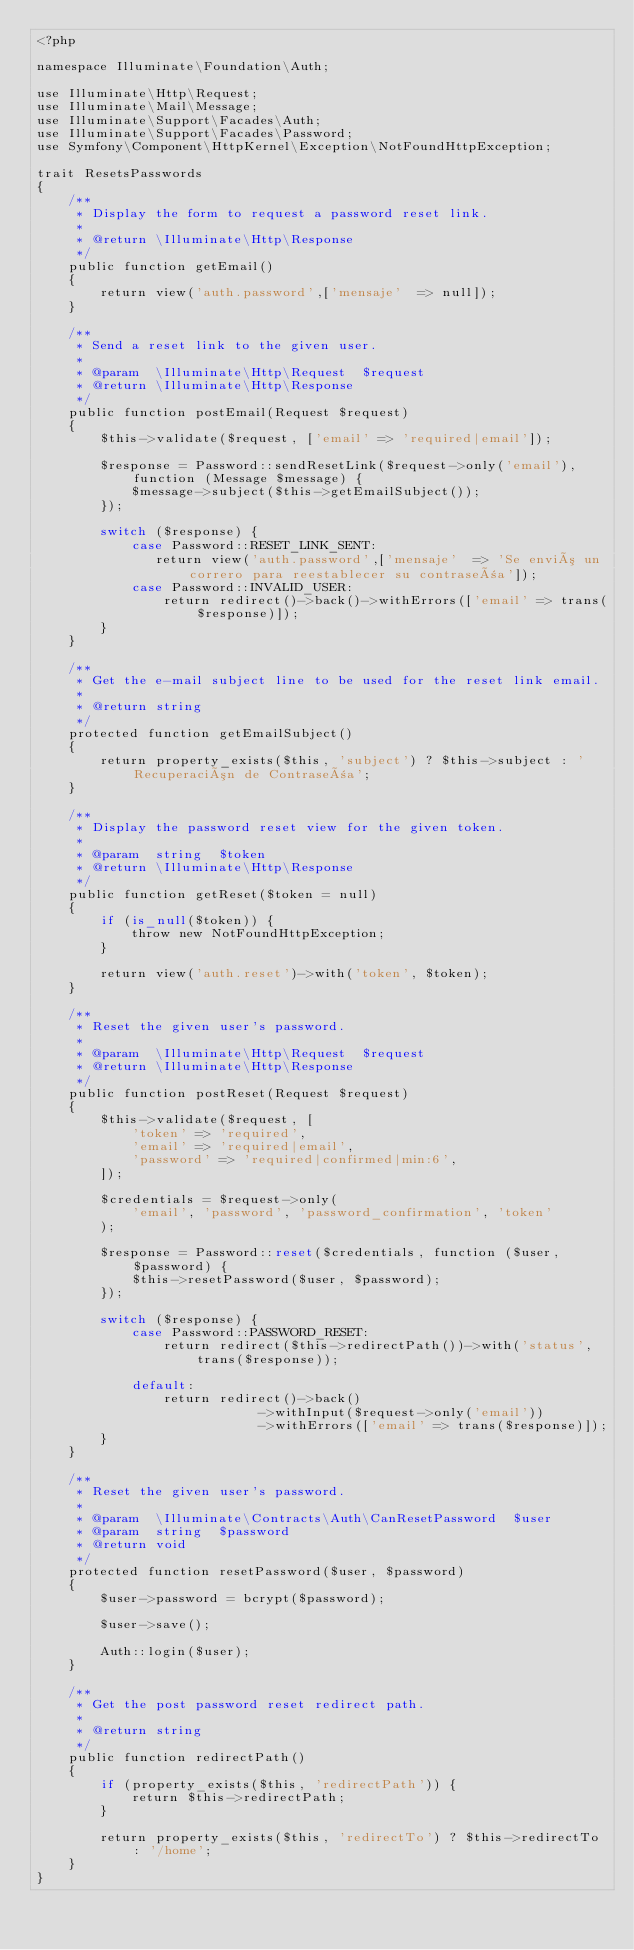Convert code to text. <code><loc_0><loc_0><loc_500><loc_500><_PHP_><?php

namespace Illuminate\Foundation\Auth;

use Illuminate\Http\Request;
use Illuminate\Mail\Message;
use Illuminate\Support\Facades\Auth;
use Illuminate\Support\Facades\Password;
use Symfony\Component\HttpKernel\Exception\NotFoundHttpException;

trait ResetsPasswords
{
    /**
     * Display the form to request a password reset link.
     *
     * @return \Illuminate\Http\Response
     */
    public function getEmail()
    {
        return view('auth.password',['mensaje'  => null]);
    }

    /**
     * Send a reset link to the given user.
     *
     * @param  \Illuminate\Http\Request  $request
     * @return \Illuminate\Http\Response
     */
    public function postEmail(Request $request)
    {
        $this->validate($request, ['email' => 'required|email']);

        $response = Password::sendResetLink($request->only('email'), function (Message $message) {
            $message->subject($this->getEmailSubject());
        });

        switch ($response) {
            case Password::RESET_LINK_SENT:
               return view('auth.password',['mensaje'  => 'Se envió un correro para reestablecer su contraseña']);
            case Password::INVALID_USER:
                return redirect()->back()->withErrors(['email' => trans($response)]);
        }
    }

    /**
     * Get the e-mail subject line to be used for the reset link email.
     *
     * @return string
     */
    protected function getEmailSubject()
    {
        return property_exists($this, 'subject') ? $this->subject : 'Recuperación de Contraseña';
    }

    /**
     * Display the password reset view for the given token.
     *
     * @param  string  $token
     * @return \Illuminate\Http\Response
     */
    public function getReset($token = null)
    {
        if (is_null($token)) {
            throw new NotFoundHttpException;
        }

        return view('auth.reset')->with('token', $token);
    }

    /**
     * Reset the given user's password.
     *
     * @param  \Illuminate\Http\Request  $request
     * @return \Illuminate\Http\Response
     */
    public function postReset(Request $request)
    {
        $this->validate($request, [
            'token' => 'required',
            'email' => 'required|email',
            'password' => 'required|confirmed|min:6',
        ]);

        $credentials = $request->only(
            'email', 'password', 'password_confirmation', 'token'
        );

        $response = Password::reset($credentials, function ($user, $password) {
            $this->resetPassword($user, $password);
        });

        switch ($response) {
            case Password::PASSWORD_RESET:
                return redirect($this->redirectPath())->with('status', trans($response));

            default:
                return redirect()->back()
                            ->withInput($request->only('email'))
                            ->withErrors(['email' => trans($response)]);
        }
    }

    /**
     * Reset the given user's password.
     *
     * @param  \Illuminate\Contracts\Auth\CanResetPassword  $user
     * @param  string  $password
     * @return void
     */
    protected function resetPassword($user, $password)
    {
        $user->password = bcrypt($password);

        $user->save();

        Auth::login($user);
    }

    /**
     * Get the post password reset redirect path.
     *
     * @return string
     */
    public function redirectPath()
    {
        if (property_exists($this, 'redirectPath')) {
            return $this->redirectPath;
        }

        return property_exists($this, 'redirectTo') ? $this->redirectTo : '/home';
    }
}
</code> 